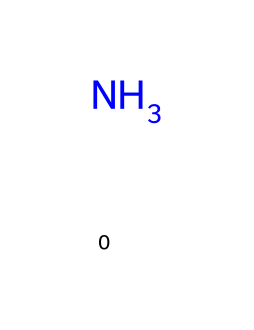What is the name of this chemical? The chemical structure displays a single nitrogen atom, which corresponds to ammonia. Therefore, its common name is ammonia.
Answer: ammonia How many atoms are present in this molecule? The SMILES representation shows only one nitrogen atom with no additional atoms, indicating that there is one atom in total.
Answer: 1 What type of bonding is exhibited in this molecule? The structure with the nitrogen atom indicates that it has covalent bonding, as nitrogen typically forms bonds by sharing electrons with other atoms.
Answer: covalent Is ammonia a natural refrigerant? Ammonia is widely recognized as a natural refrigerant due to its efficiency and low environmental impact compared to synthetic refrigerants.
Answer: yes What is the role of ammonia in ecosystems regarding refrigeration? In ecosystems, ammonia acts to regulate temperature and maintain biological activity, functioning as a natural refrigerant by absorbing heat efficiently.
Answer: naturally cools Why is ammonia more efficient as a refrigerant compared to many synthetic options? Ammonia has favorable thermodynamic properties including a higher heat capacity, which allows it to absorb and release heat more effectively than many synthetic refrigerants.
Answer: higher efficiency 